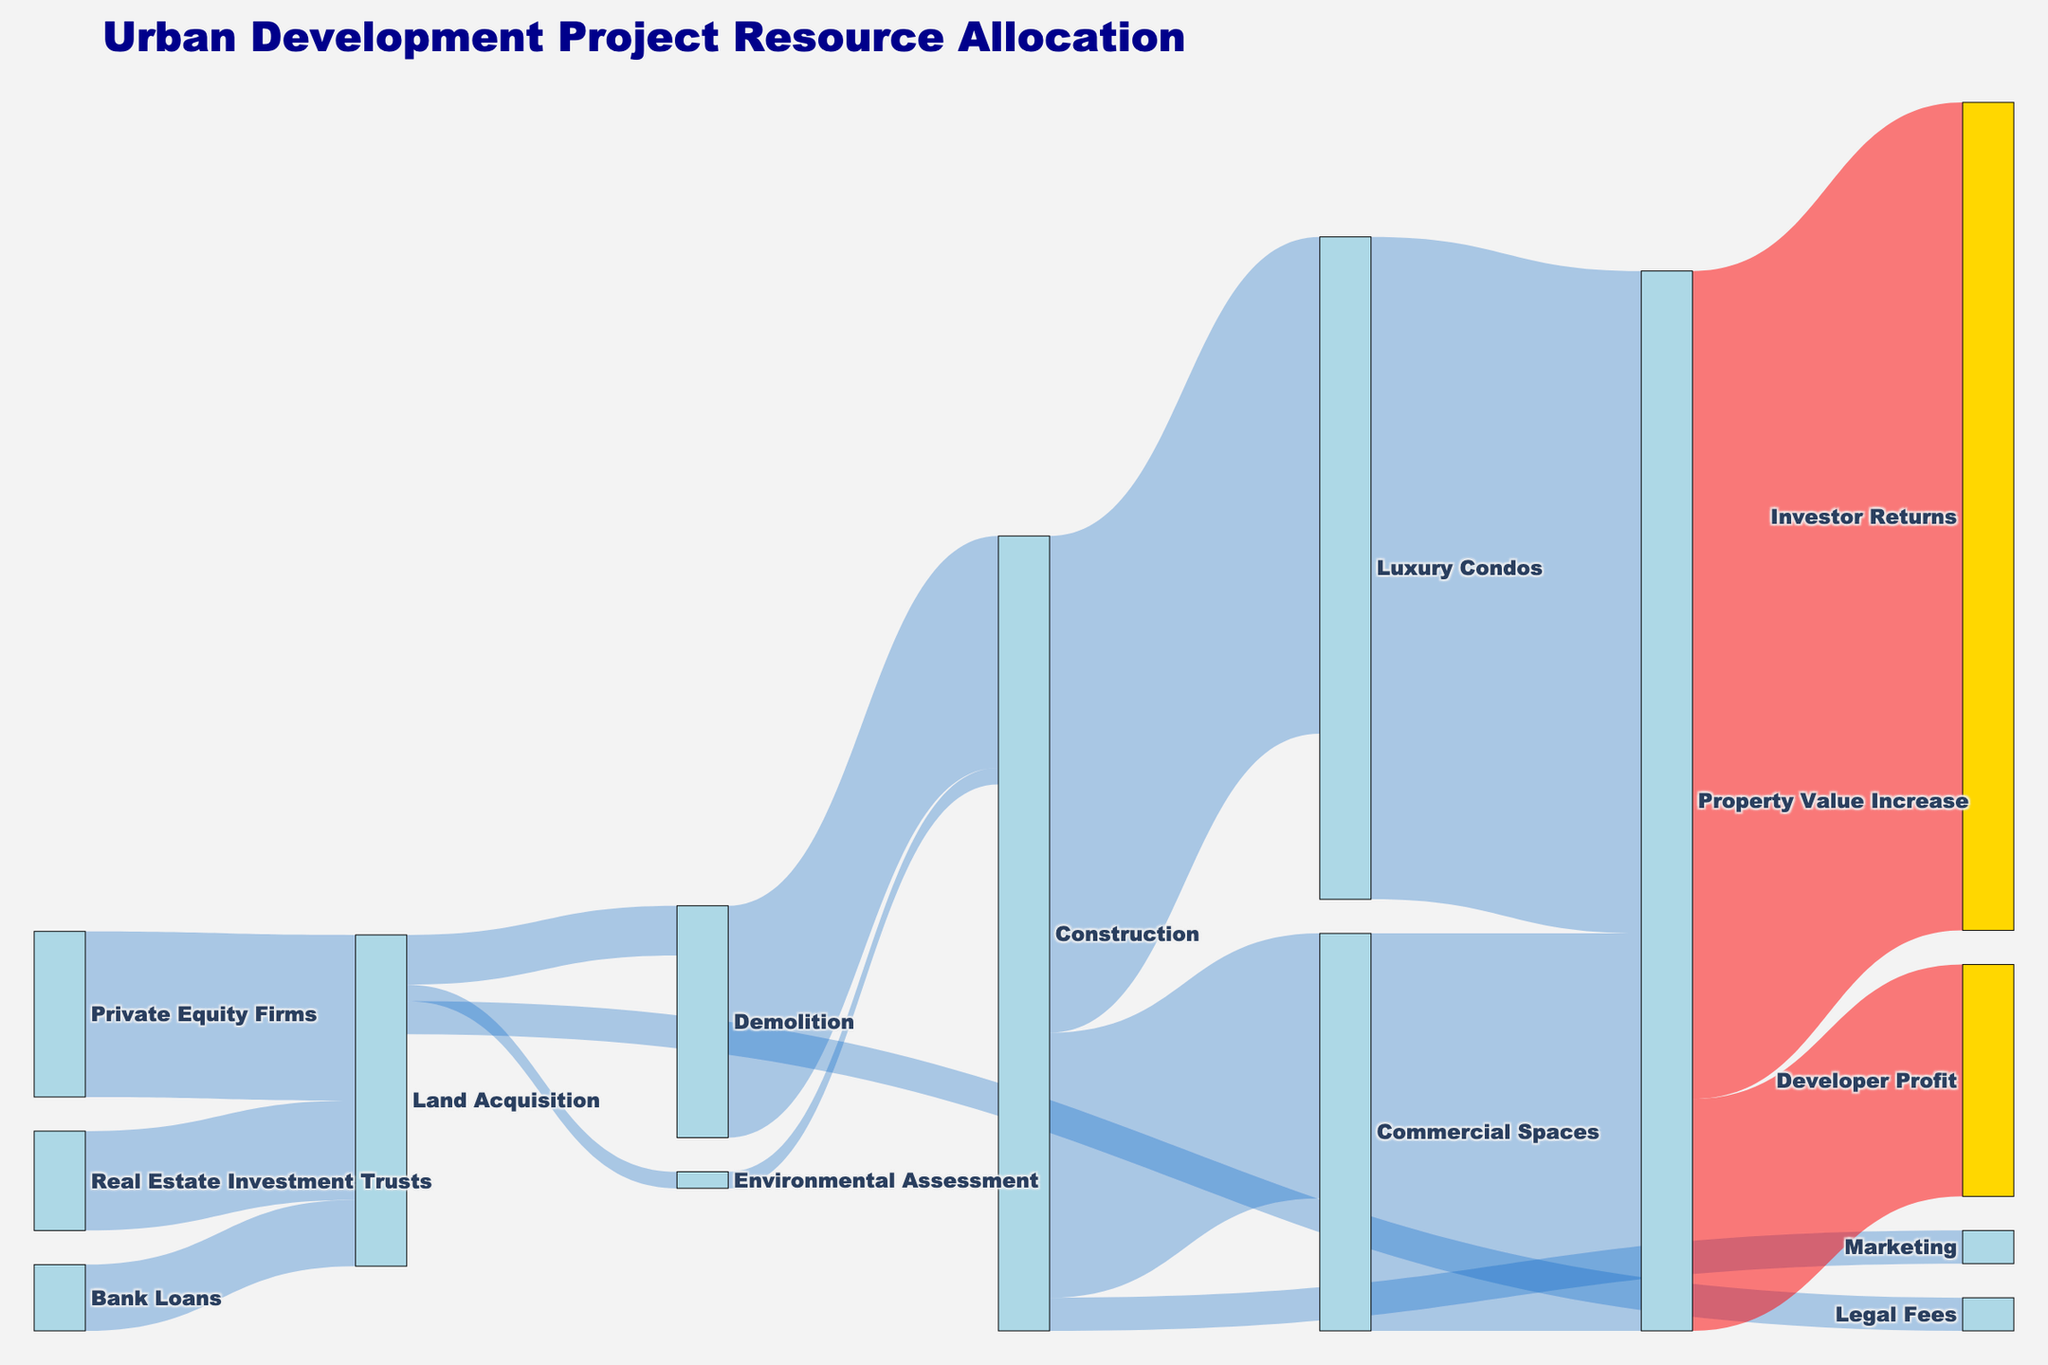What is the title of the figure? The title of the figure is displayed at the top of the Sankey diagram in a larger font size and different color.
Answer: Urban Development Project Resource Allocation Which funding source contributes the most to the Land Acquisition stage? By examining the thickness and value associated with each inflow into Land Acquisition, Private Equity Firms contribute the most with 50,000,000.
Answer: Private Equity Firms What is the total investment received for the Land Acquisition stage? Sum the values of all fund sources contributing to Land Acquisition: Private Equity Firms (50M) + Real Estate Investment Trusts (30M) + Bank Loans (20M).
Answer: 100,000,000 How much is allocated from Land Acquisition to Legal Fees? Look at the value connected from Land Acquisition to Legal Fees in the diagram.
Answer: 10,000,000 How much more is allocated from Construction to Luxury Condos compared to Commercial Spaces? Compare the values going from Construction to Luxury Condos (150M) and Commercial Spaces (80M). The difference is 150M - 80M.
Answer: 70,000,000 Which stage follows after the Demolition in the resource flow? Trace the arrows following the Demolition stage to find the next stage in the process.
Answer: Construction Identify the stages that lead to a Property Value Increase. Follow the arrows pointing to Property Value Increase, which display their source stages: Luxury Condos and Commercial Spaces.
Answer: Luxury Condos, Commercial Spaces What percentage of the Construction stage's output is directed towards Marketing? Calculate the proportion of value directed towards Marketing (10M) over the total output from Construction (Luxury Condos + Commercial Spaces + Marketing = 150M + 80M + 10M).
Answer: 4.17% Which area contributes the highest value to Investor Returns? Follow the connections to Investor Returns and compare their values; Property Value Increase leads to Investor Returns with 250M.
Answer: Property Value Increase What is the final profit of the developer? Look at the final stage labeled as Developer Profit.
Answer: 70,000,000 